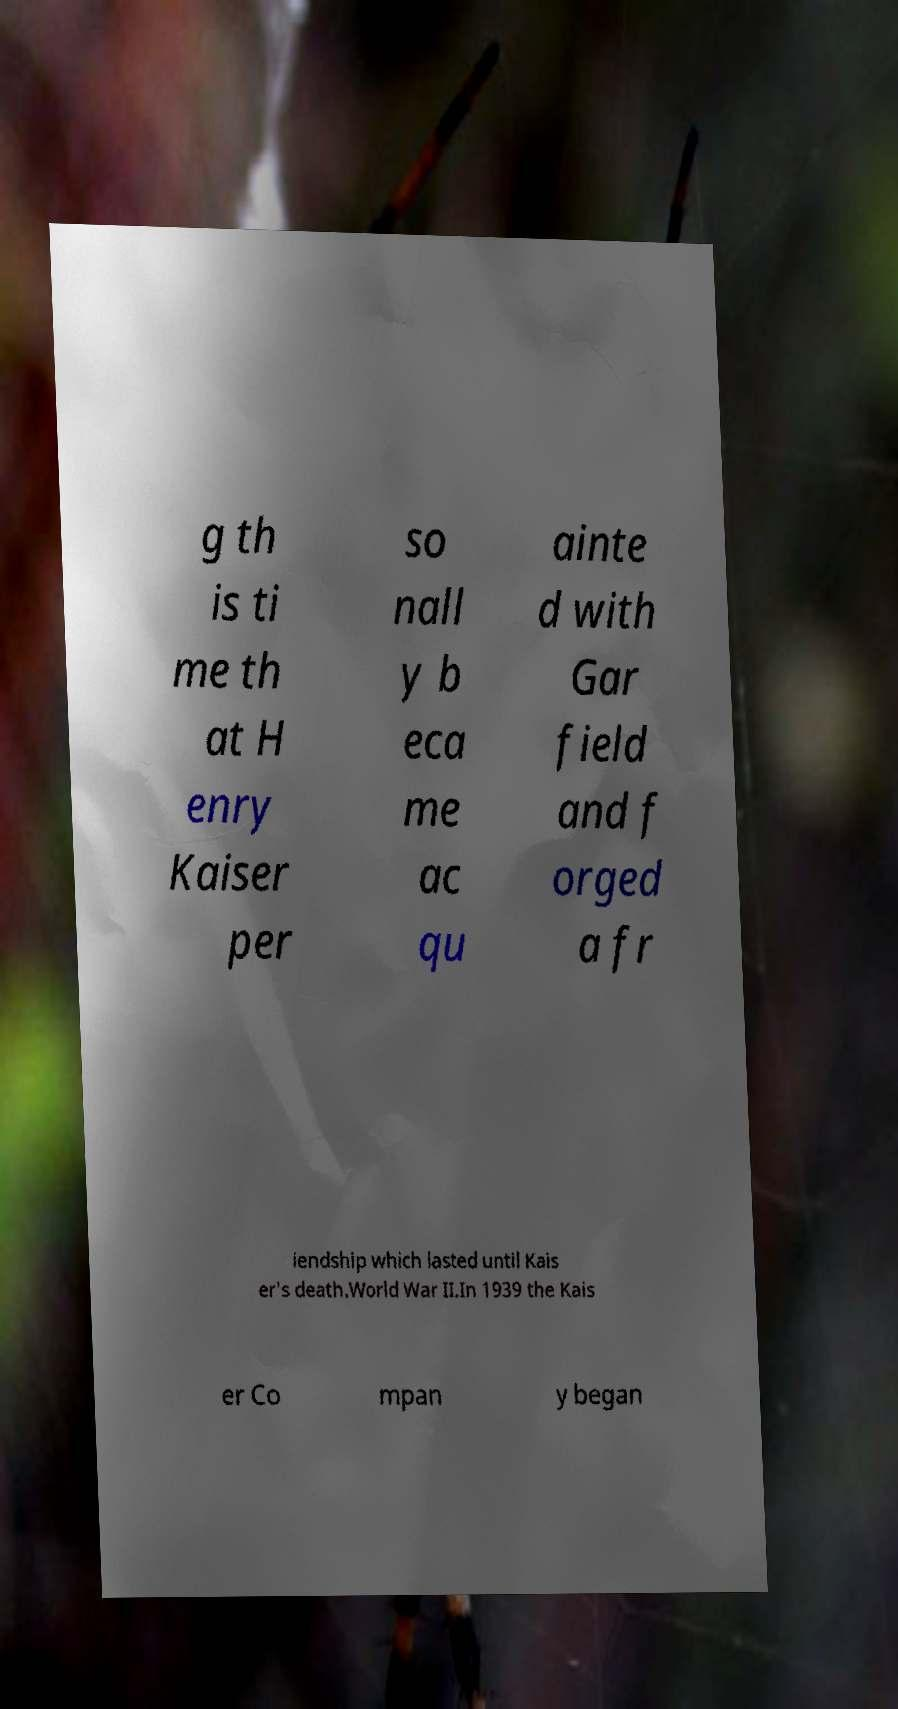Please read and relay the text visible in this image. What does it say? g th is ti me th at H enry Kaiser per so nall y b eca me ac qu ainte d with Gar field and f orged a fr iendship which lasted until Kais er's death.World War II.In 1939 the Kais er Co mpan y began 